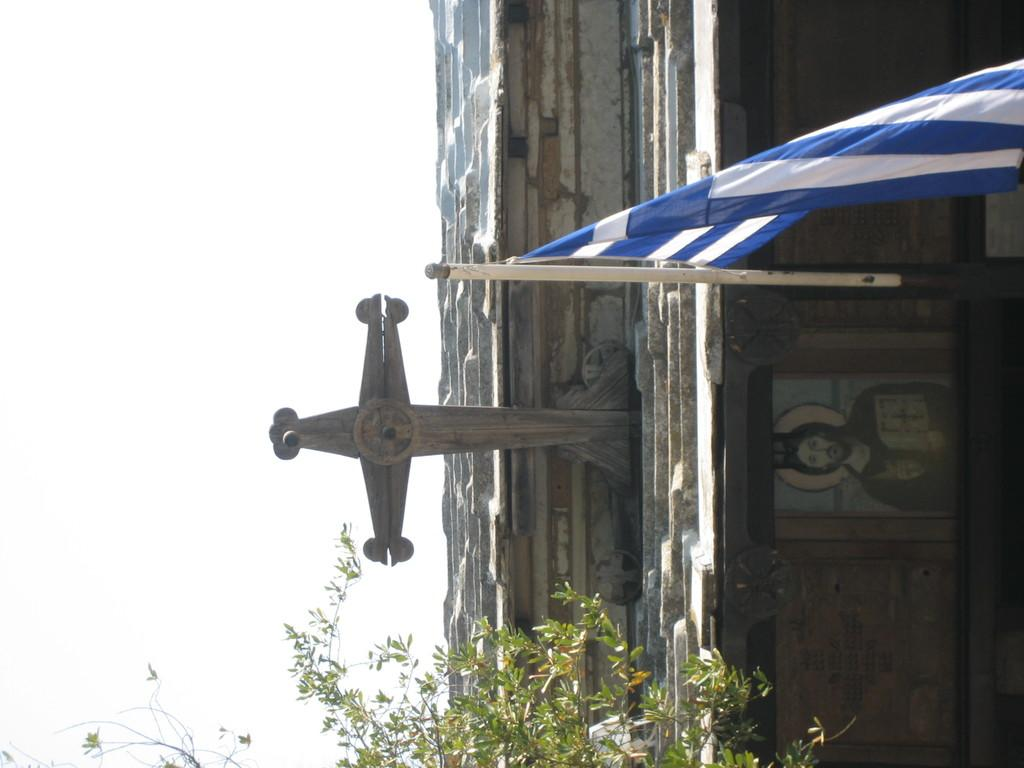What religious symbol is present on the house in the image? There is a cross on the house in the image. What structure is visible in the image for displaying a flag? There is a flag pole in the image. What type of plant is present in the image? There is a tree in the image. What is hanging on the wall in the image? There is a photo frame on the wall in the image. How would you describe the weather in the image? The sky is cloudy in the image. How does the island in the image compare to the size of the house? There is no island present in the image; it only features a house, a flag pole, a tree, a photo frame, and a cloudy sky. What emotion does the disgusting object in the image evoke? There is no disgusting object present in the image. 